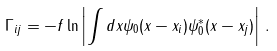<formula> <loc_0><loc_0><loc_500><loc_500>\Gamma _ { i j } = - f \ln \left | \int d x \psi _ { 0 } ( x - x _ { i } ) \psi _ { 0 } ^ { * } ( x - x _ { j } ) \right | \, .</formula> 